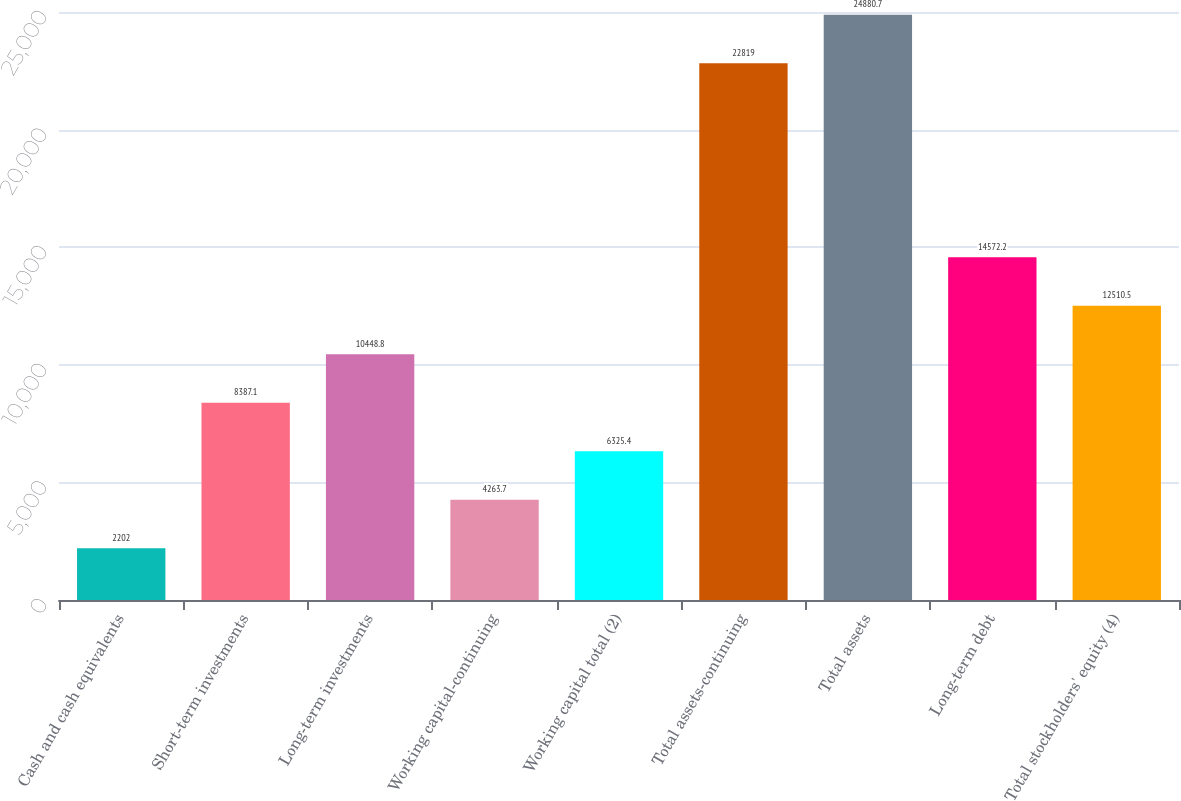<chart> <loc_0><loc_0><loc_500><loc_500><bar_chart><fcel>Cash and cash equivalents<fcel>Short-term investments<fcel>Long-term investments<fcel>Working capital-continuing<fcel>Working capital total (2)<fcel>Total assets-continuing<fcel>Total assets<fcel>Long-term debt<fcel>Total stockholders' equity (4)<nl><fcel>2202<fcel>8387.1<fcel>10448.8<fcel>4263.7<fcel>6325.4<fcel>22819<fcel>24880.7<fcel>14572.2<fcel>12510.5<nl></chart> 